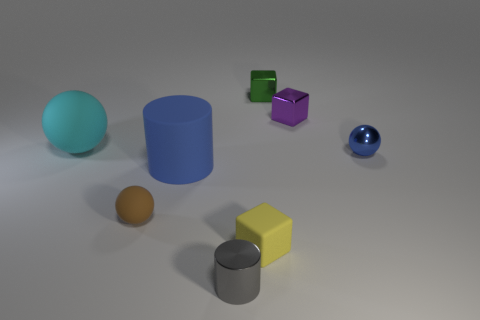Subtract all tiny metallic balls. How many balls are left? 2 Add 1 tiny red matte objects. How many objects exist? 9 Subtract all brown balls. How many balls are left? 2 Subtract all cylinders. How many objects are left? 6 Subtract 3 spheres. How many spheres are left? 0 Subtract 0 red cylinders. How many objects are left? 8 Subtract all blue cylinders. Subtract all blue blocks. How many cylinders are left? 1 Subtract all cubes. Subtract all small balls. How many objects are left? 3 Add 5 yellow rubber cubes. How many yellow rubber cubes are left? 6 Add 2 cyan matte spheres. How many cyan matte spheres exist? 3 